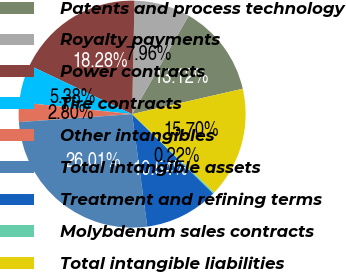Convert chart to OTSL. <chart><loc_0><loc_0><loc_500><loc_500><pie_chart><fcel>Patents and process technology<fcel>Royalty payments<fcel>Power contracts<fcel>Tire contracts<fcel>Other intangibles<fcel>Total intangible assets<fcel>Treatment and refining terms<fcel>Molybdenum sales contracts<fcel>Total intangible liabilities<nl><fcel>13.12%<fcel>7.96%<fcel>18.28%<fcel>5.38%<fcel>2.8%<fcel>26.01%<fcel>10.54%<fcel>0.22%<fcel>15.7%<nl></chart> 